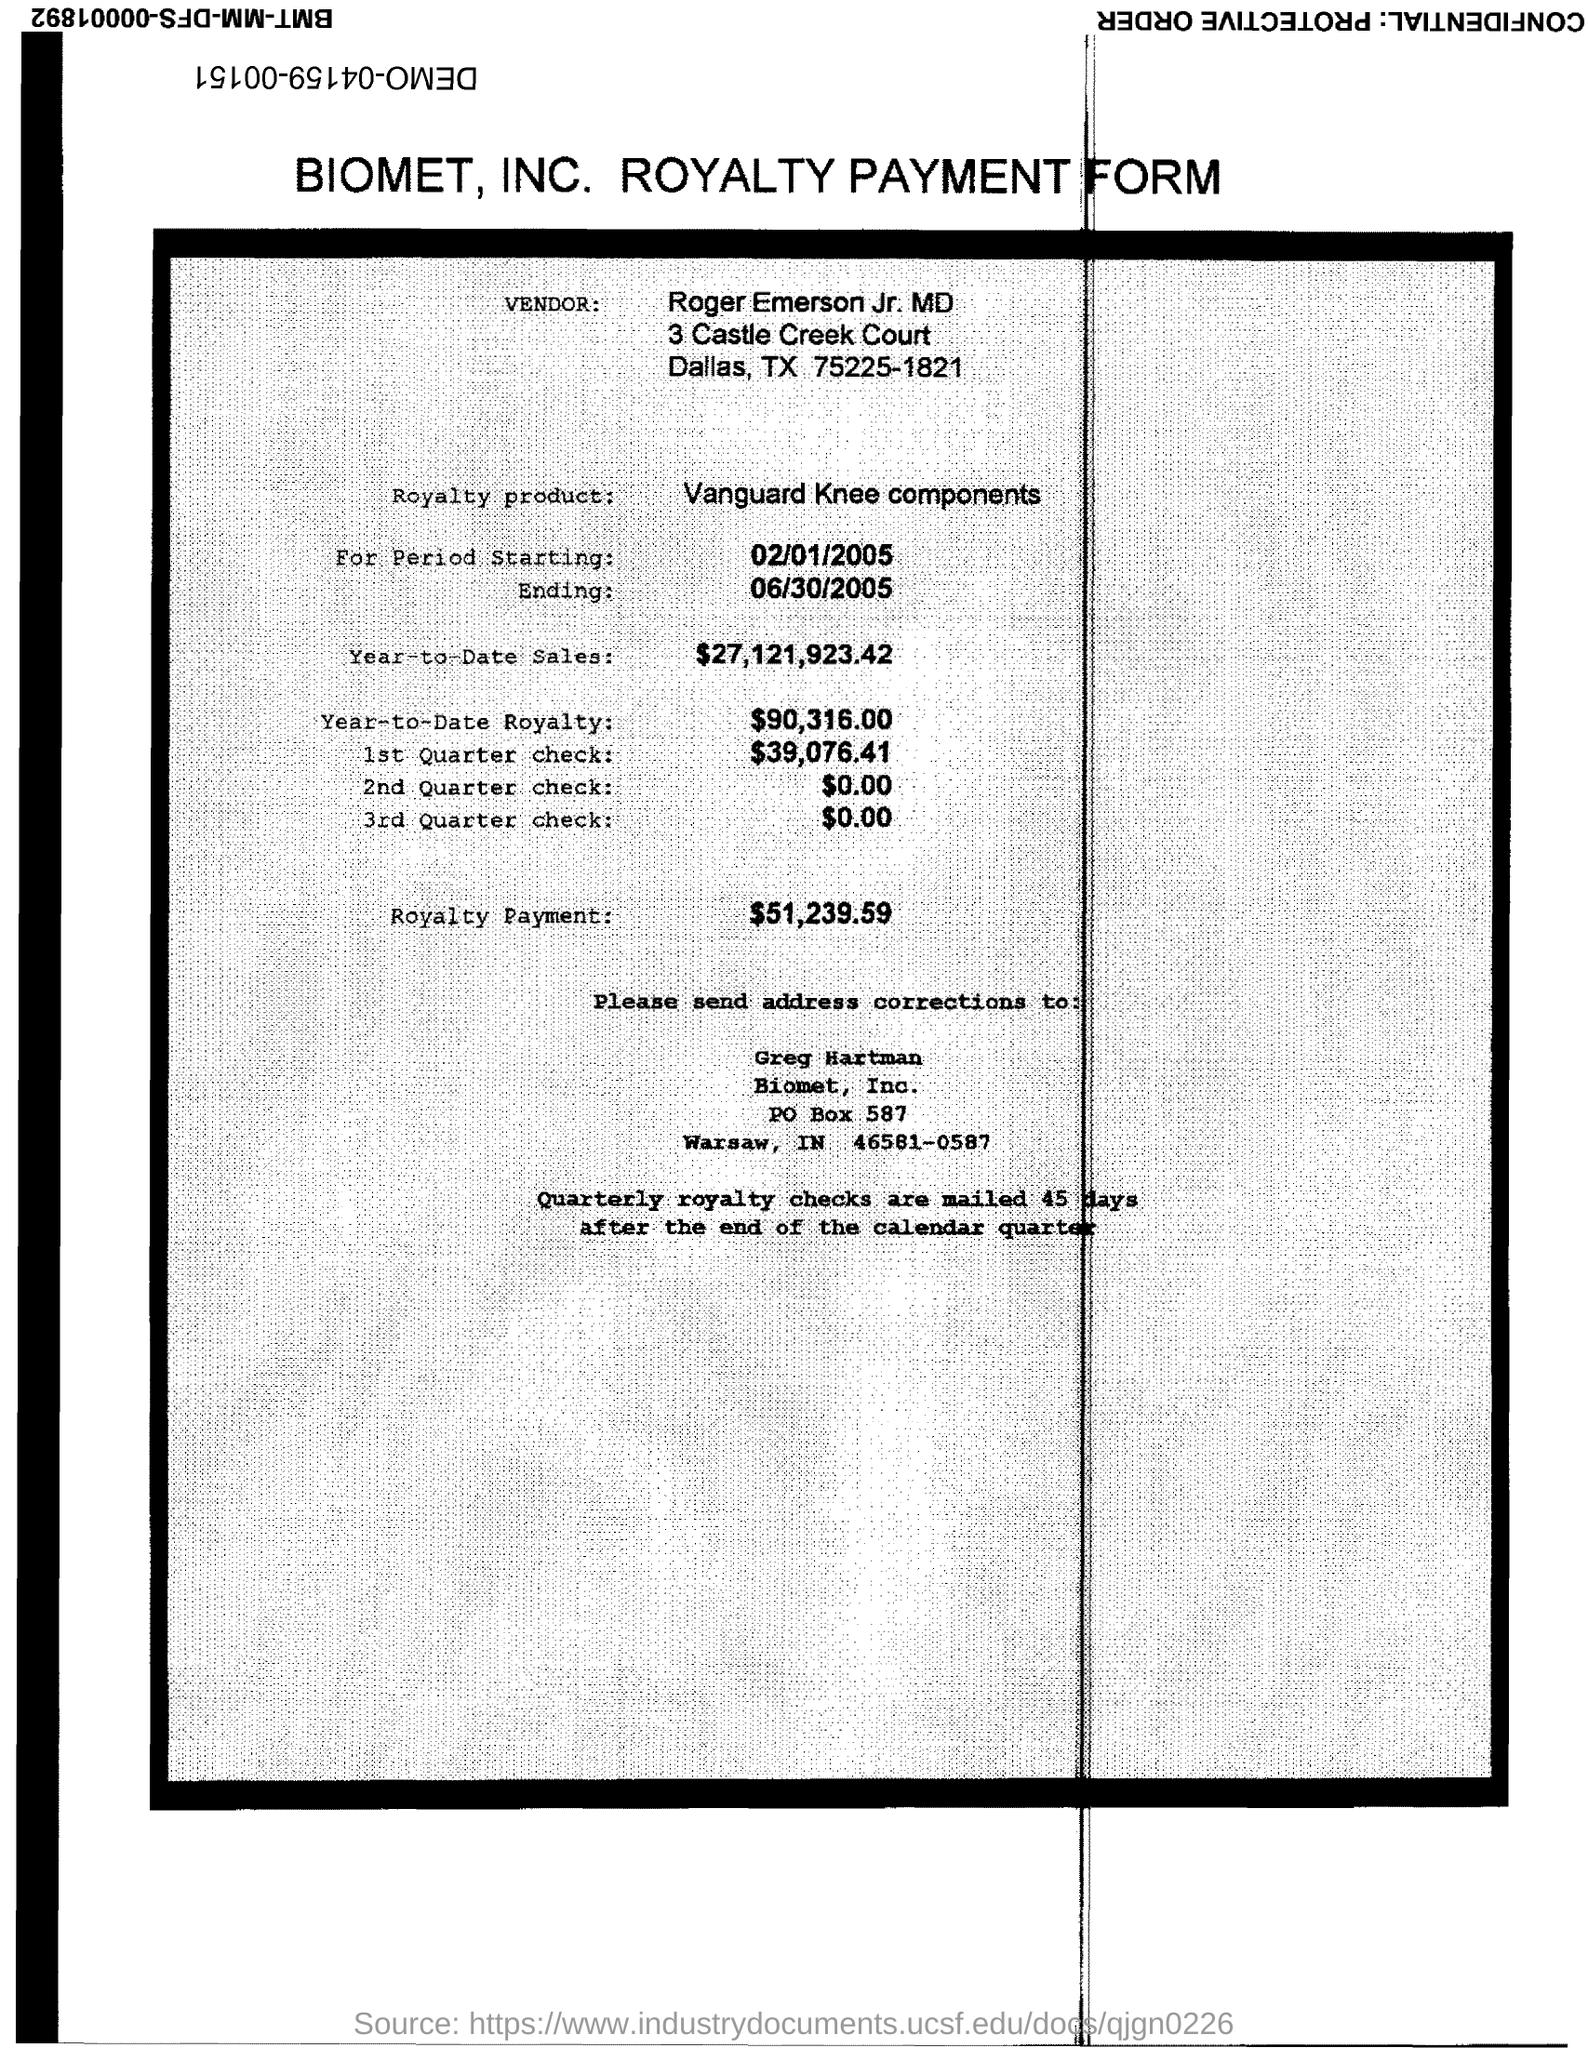Specify some key components in this picture. The amount of the 1st quarter check mentioned in the form is $39,076.41. The end date of the royalty period is June 30, 2005. Roger Emerson Jr. MD is the vendor mentioned in the form. The year-to-date sales of the royalty product are $27,121,923.42. The start date of the royalty period is February 1, 2005. 